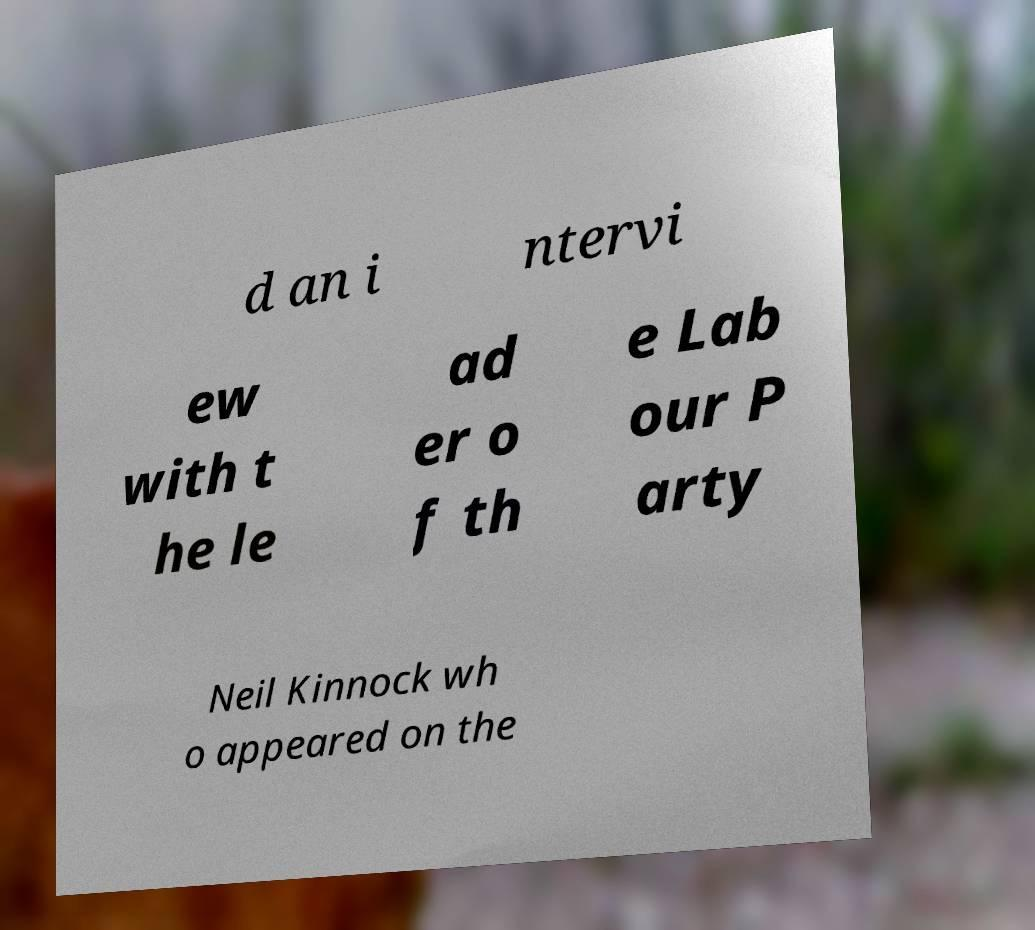Can you accurately transcribe the text from the provided image for me? d an i ntervi ew with t he le ad er o f th e Lab our P arty Neil Kinnock wh o appeared on the 